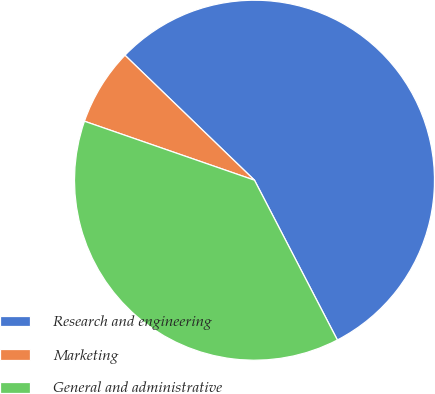Convert chart to OTSL. <chart><loc_0><loc_0><loc_500><loc_500><pie_chart><fcel>Research and engineering<fcel>Marketing<fcel>General and administrative<nl><fcel>55.17%<fcel>6.9%<fcel>37.93%<nl></chart> 